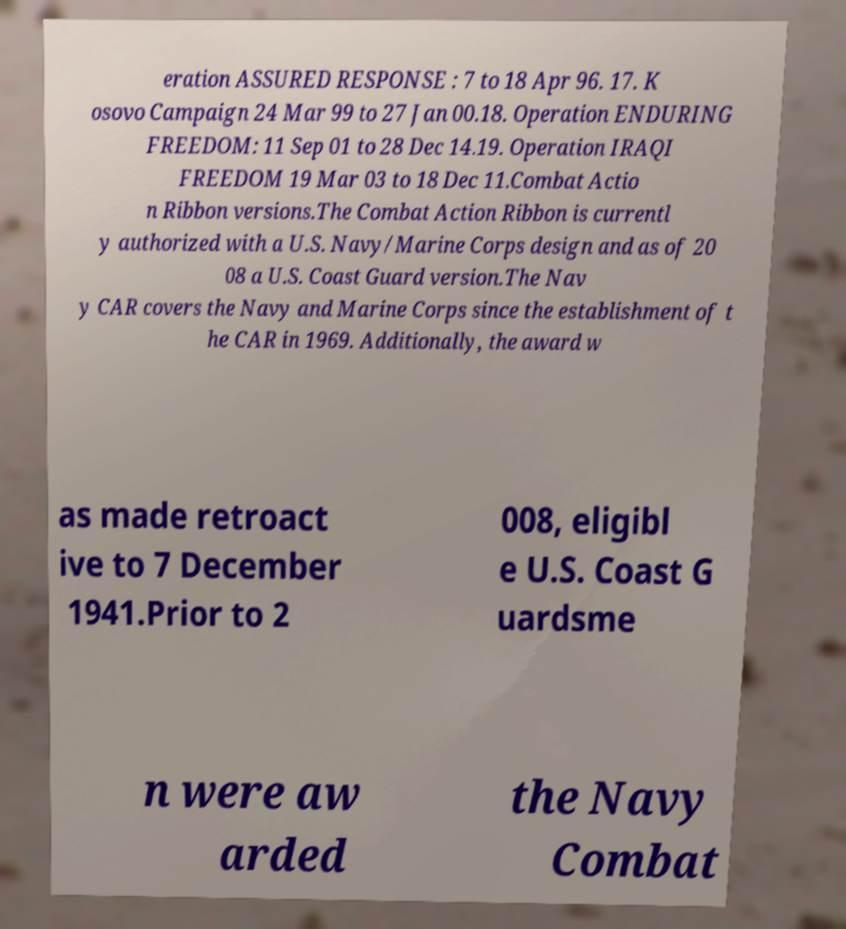Could you assist in decoding the text presented in this image and type it out clearly? eration ASSURED RESPONSE : 7 to 18 Apr 96. 17. K osovo Campaign 24 Mar 99 to 27 Jan 00.18. Operation ENDURING FREEDOM: 11 Sep 01 to 28 Dec 14.19. Operation IRAQI FREEDOM 19 Mar 03 to 18 Dec 11.Combat Actio n Ribbon versions.The Combat Action Ribbon is currentl y authorized with a U.S. Navy/Marine Corps design and as of 20 08 a U.S. Coast Guard version.The Nav y CAR covers the Navy and Marine Corps since the establishment of t he CAR in 1969. Additionally, the award w as made retroact ive to 7 December 1941.Prior to 2 008, eligibl e U.S. Coast G uardsme n were aw arded the Navy Combat 